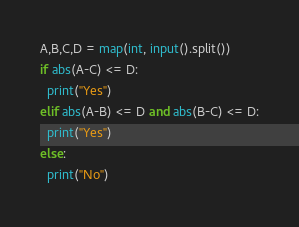<code> <loc_0><loc_0><loc_500><loc_500><_Python_>A,B,C,D = map(int, input().split())
if abs(A-C) <= D:
  print("Yes")
elif abs(A-B) <= D and abs(B-C) <= D:
  print("Yes")
else:
  print("No")</code> 